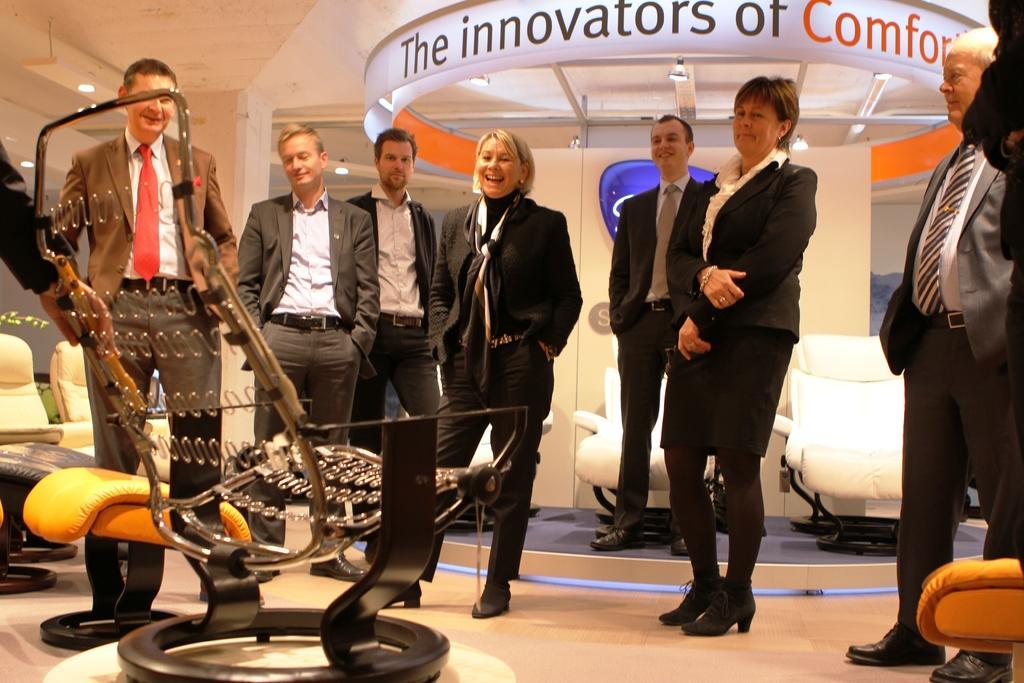In one or two sentences, can you explain what this image depicts? In the center of the image we can see a few people are standing and they are in different costumes. And we can see they are smiling. On the left side of the image, we can see the hand of a person holding a chair. At the bottom right side of the image, we can see an object. In the background there is a wall, board with some text, chairs, lights and a few other objects. 